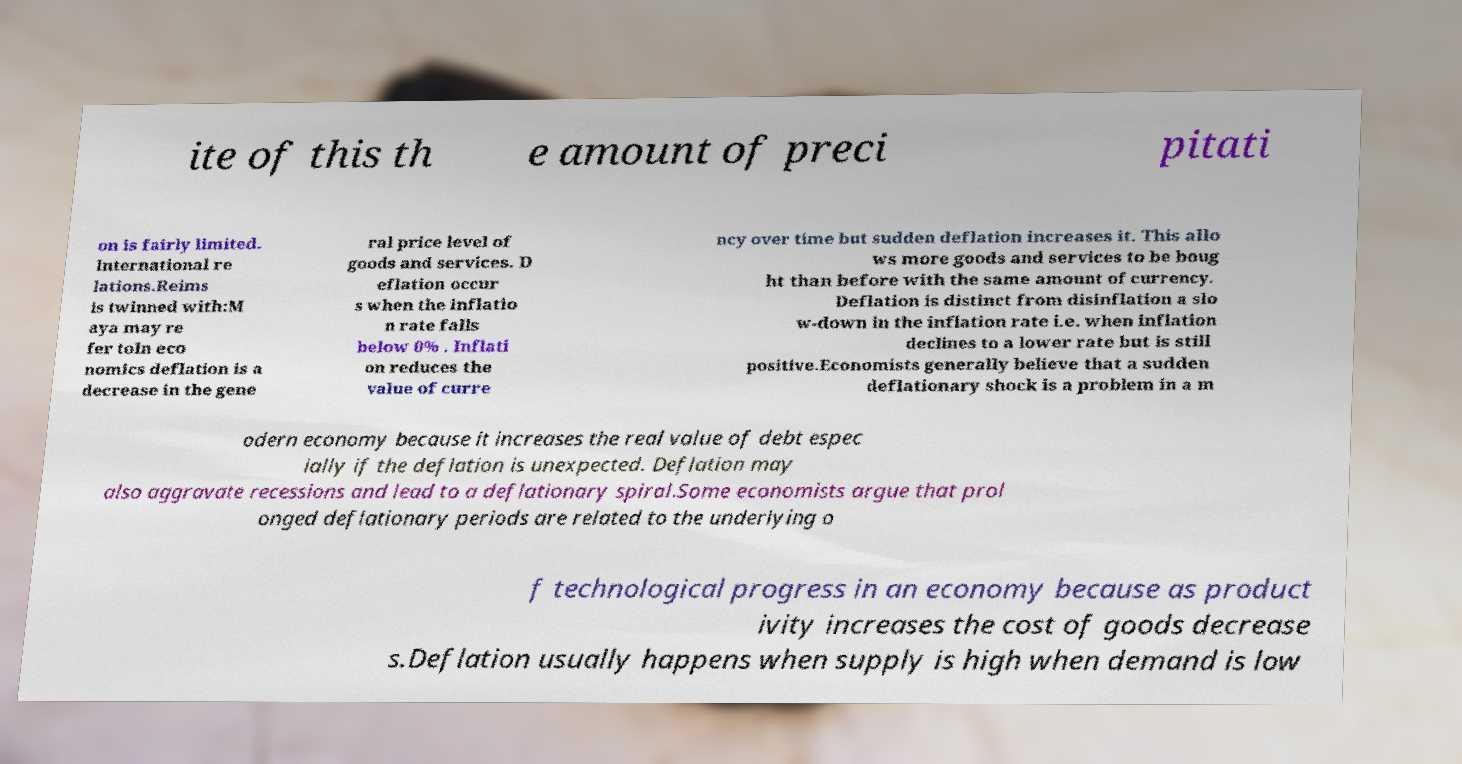Can you read and provide the text displayed in the image?This photo seems to have some interesting text. Can you extract and type it out for me? ite of this th e amount of preci pitati on is fairly limited. International re lations.Reims is twinned with:M aya may re fer toIn eco nomics deflation is a decrease in the gene ral price level of goods and services. D eflation occur s when the inflatio n rate falls below 0% . Inflati on reduces the value of curre ncy over time but sudden deflation increases it. This allo ws more goods and services to be boug ht than before with the same amount of currency. Deflation is distinct from disinflation a slo w-down in the inflation rate i.e. when inflation declines to a lower rate but is still positive.Economists generally believe that a sudden deflationary shock is a problem in a m odern economy because it increases the real value of debt espec ially if the deflation is unexpected. Deflation may also aggravate recessions and lead to a deflationary spiral.Some economists argue that prol onged deflationary periods are related to the underlying o f technological progress in an economy because as product ivity increases the cost of goods decrease s.Deflation usually happens when supply is high when demand is low 